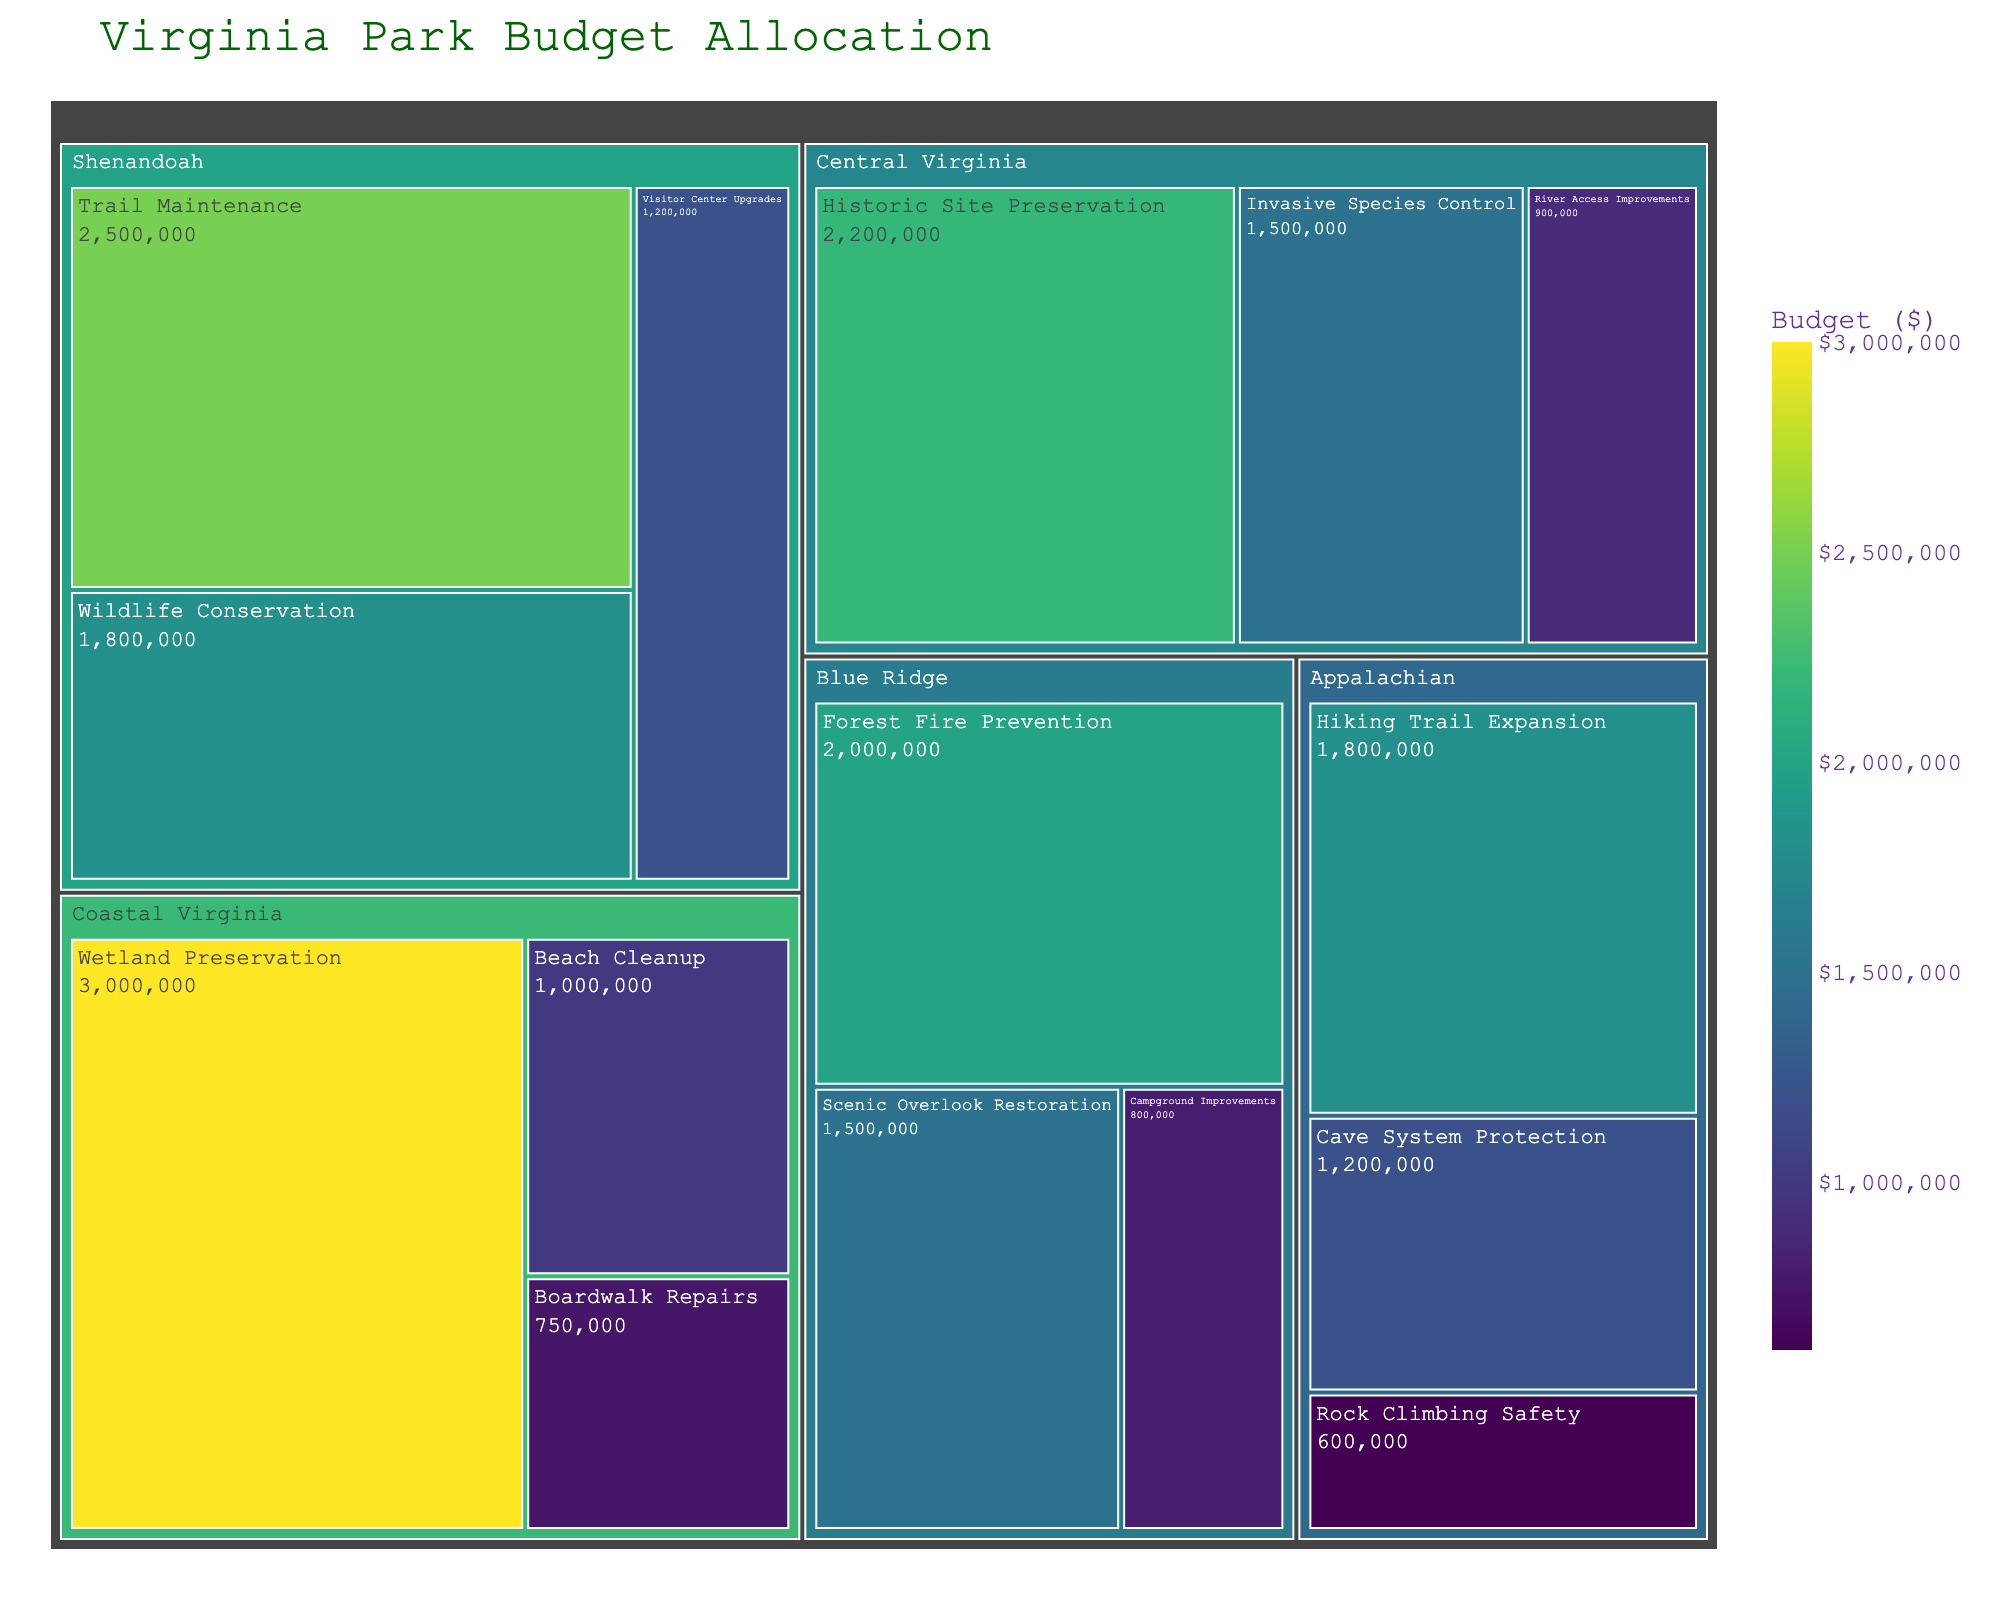What is the title of the treemap? The title is usually found at the top of the figure and provides a quick summary of what the visual represents.
Answer: Virginia Park Budget Allocation Which region received the highest budget for a single project? To find this, you need to identify the project tile with the largest budget amount. In this case, it's in the "Coastal Virginia" region for "Wetland Preservation."
Answer: Coastal Virginia How many projects are within the Blue Ridge region? Look for all the sections in the treemap under the "Blue Ridge" division and count them.
Answer: 3 What’s the total budget allocated for the Shenandoah region? Add up all the individual project budgets within the Shenandoah region: 2,500,000 + 1,800,000 + 1,200,000 = 5,500,000
Answer: 5,500,000 What is the smallest budget allocated to any project and which project is it? Find the smallest budget value by comparing all the individual project budgets. In this case, it's "Rock Climbing Safety" in the Appalachian region.
Answer: 600,000 Which region has a greater budget for conservation efforts, Shenandoah or Coastal Virginia? To answer this, compare the relevant budgets. Shenandoah's "Wildlife Conservation" has 1,800,000, and Coastal Virginia's "Wetland Preservation" has 3,000,000.
Answer: Coastal Virginia What is the average budget for projects in Central Virginia? First, sum up the budgets: 2,200,000 + 900,000 + 1,500,000 = 4,600,000. Then, divide by the number of projects, which is 3. So, 4,600,000 / 3 ≈ 1,533,333.33
Answer: 1,533,333.33 Which project in Shenandoah has the smallest budget? Look within the Shenandoah region and find the project with the smallest budget. Here, it is "Visitor Center Upgrades" with 1,200,000.
Answer: Visitor Center Upgrades What is the budget difference between the highest and lowest budgeted projects? Identify the highest budget (Wetland Preservation, 3,000,000) and the lowest budget (Rock Climbing Safety, 600,000), then calculate the difference: 3,000,000 - 600,000 = 2,400,000
Answer: 2,400,000 Which region has projects with more than 2 million budget allocations? Scan through the regions and their projects to find any project with a budget over 2 million. Both Shenandoah and Coastal Virginia have projects with a budget over 2 million.
Answer: Shenandoah and Coastal Virginia 